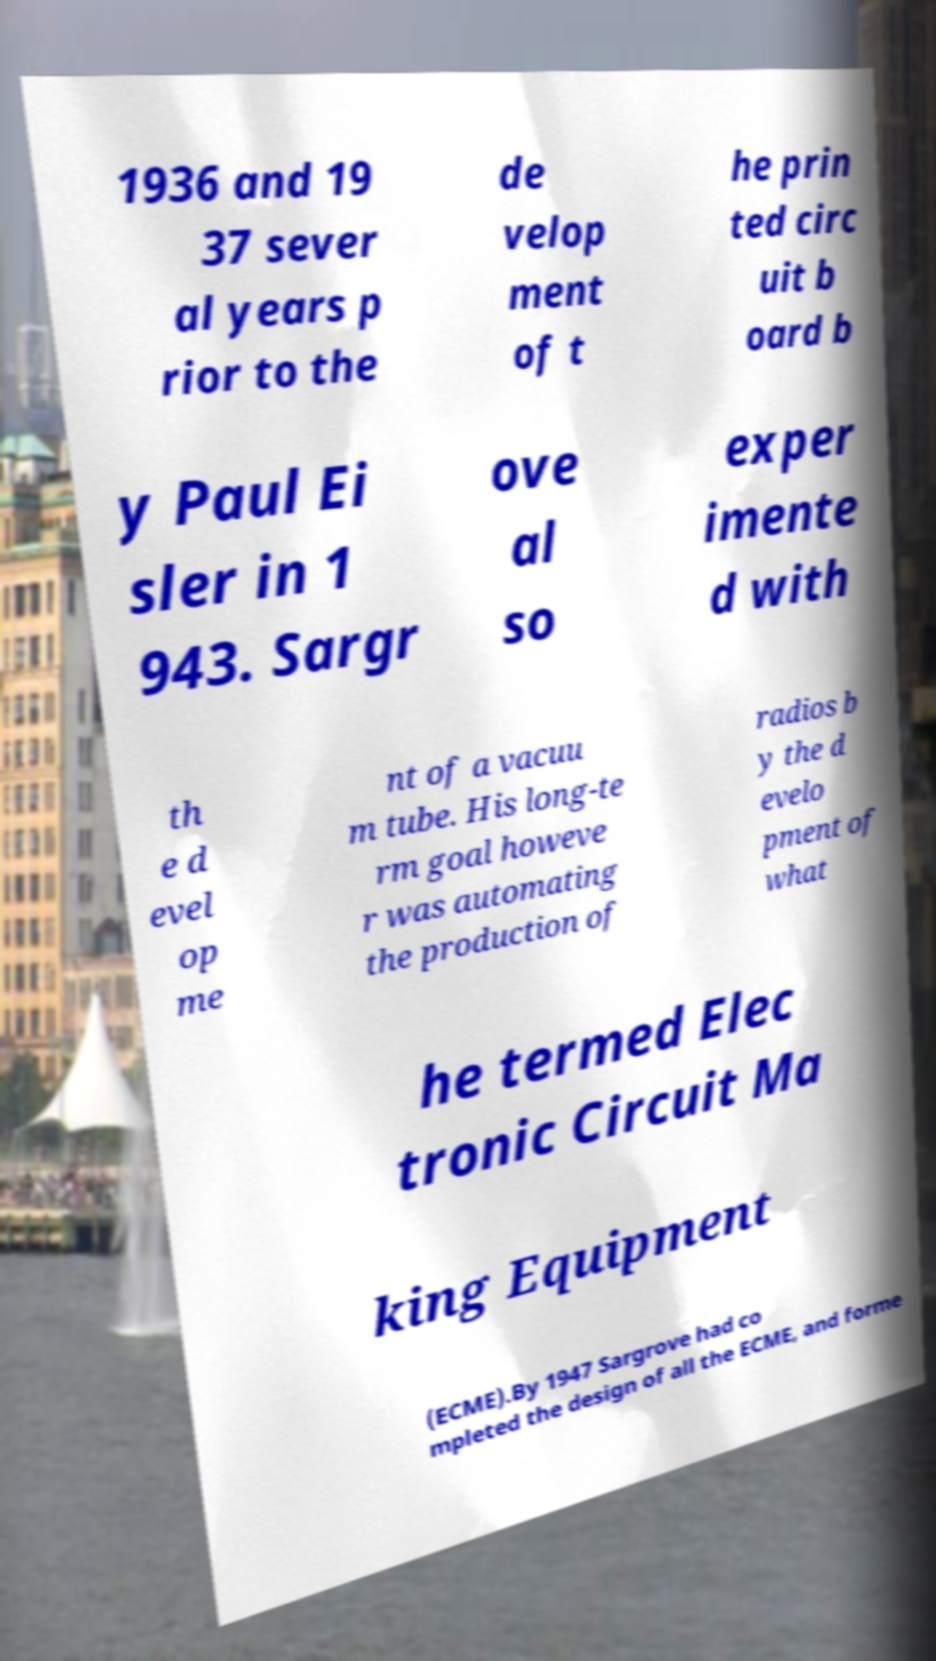There's text embedded in this image that I need extracted. Can you transcribe it verbatim? 1936 and 19 37 sever al years p rior to the de velop ment of t he prin ted circ uit b oard b y Paul Ei sler in 1 943. Sargr ove al so exper imente d with th e d evel op me nt of a vacuu m tube. His long-te rm goal howeve r was automating the production of radios b y the d evelo pment of what he termed Elec tronic Circuit Ma king Equipment (ECME).By 1947 Sargrove had co mpleted the design of all the ECME, and forme 